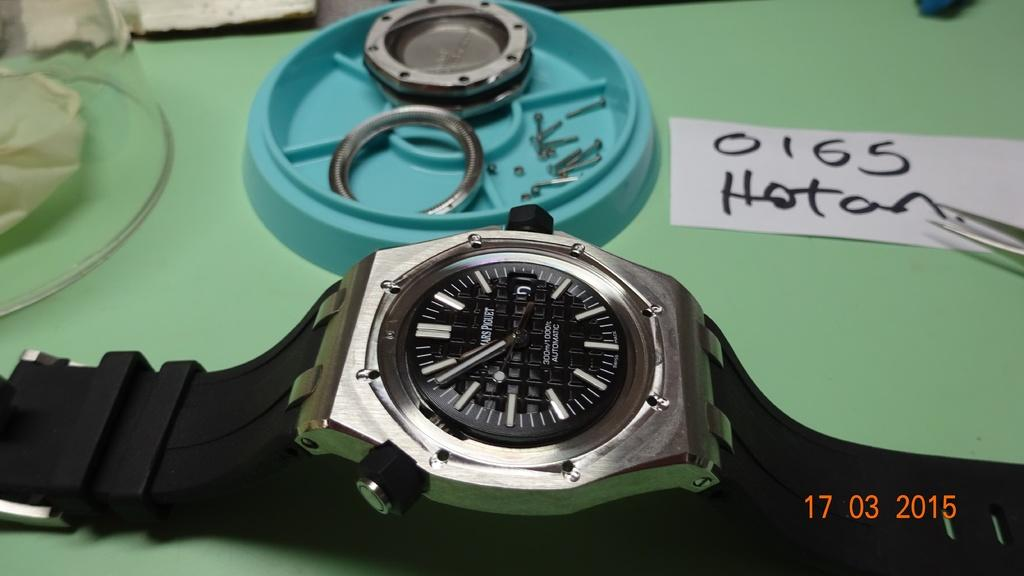<image>
Present a compact description of the photo's key features. A wristwatch on a green table in near a sign with the name Hotan on it. 